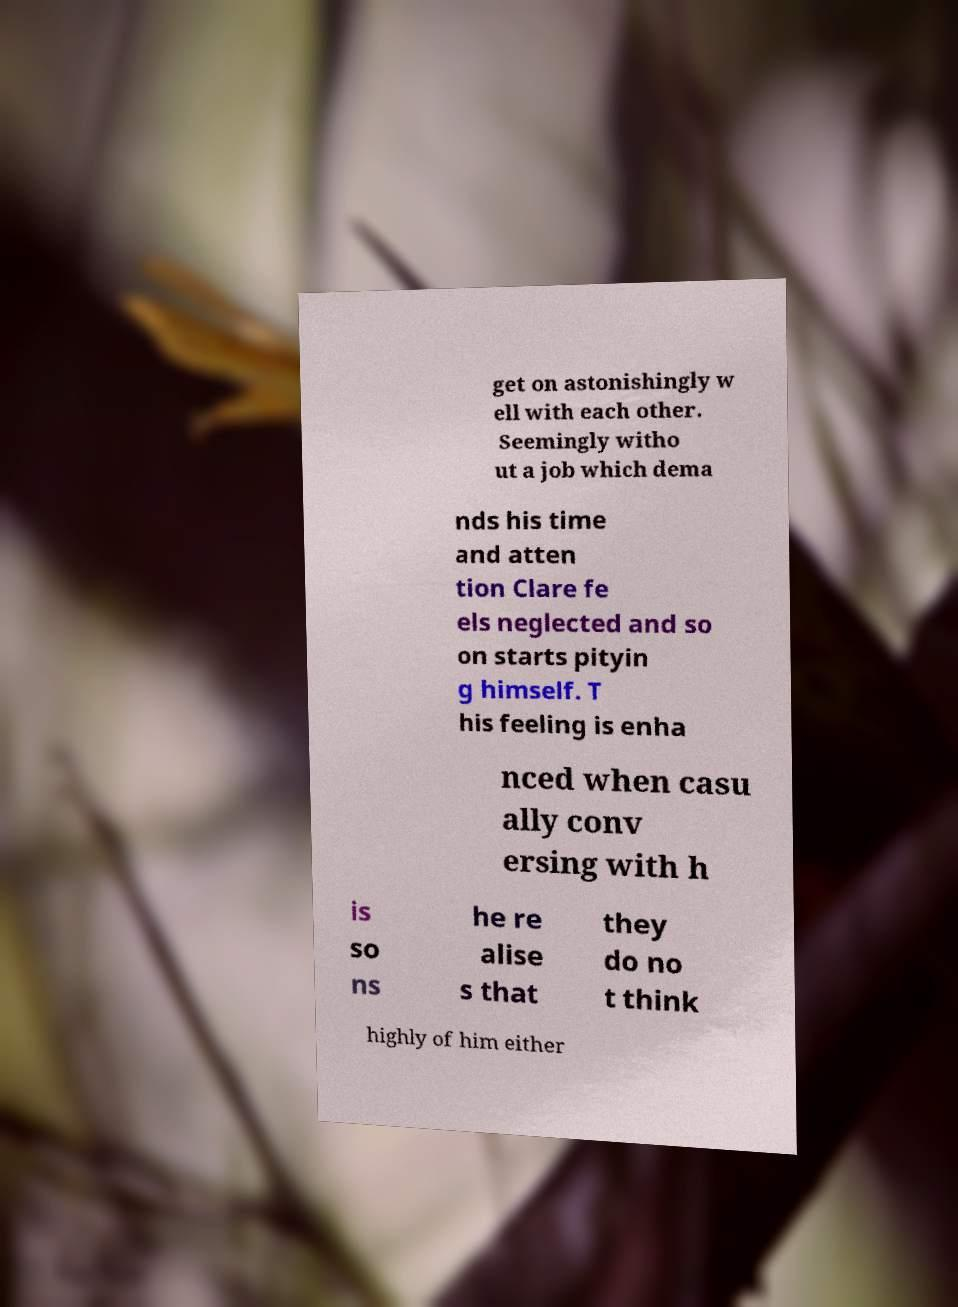I need the written content from this picture converted into text. Can you do that? get on astonishingly w ell with each other. Seemingly witho ut a job which dema nds his time and atten tion Clare fe els neglected and so on starts pityin g himself. T his feeling is enha nced when casu ally conv ersing with h is so ns he re alise s that they do no t think highly of him either 